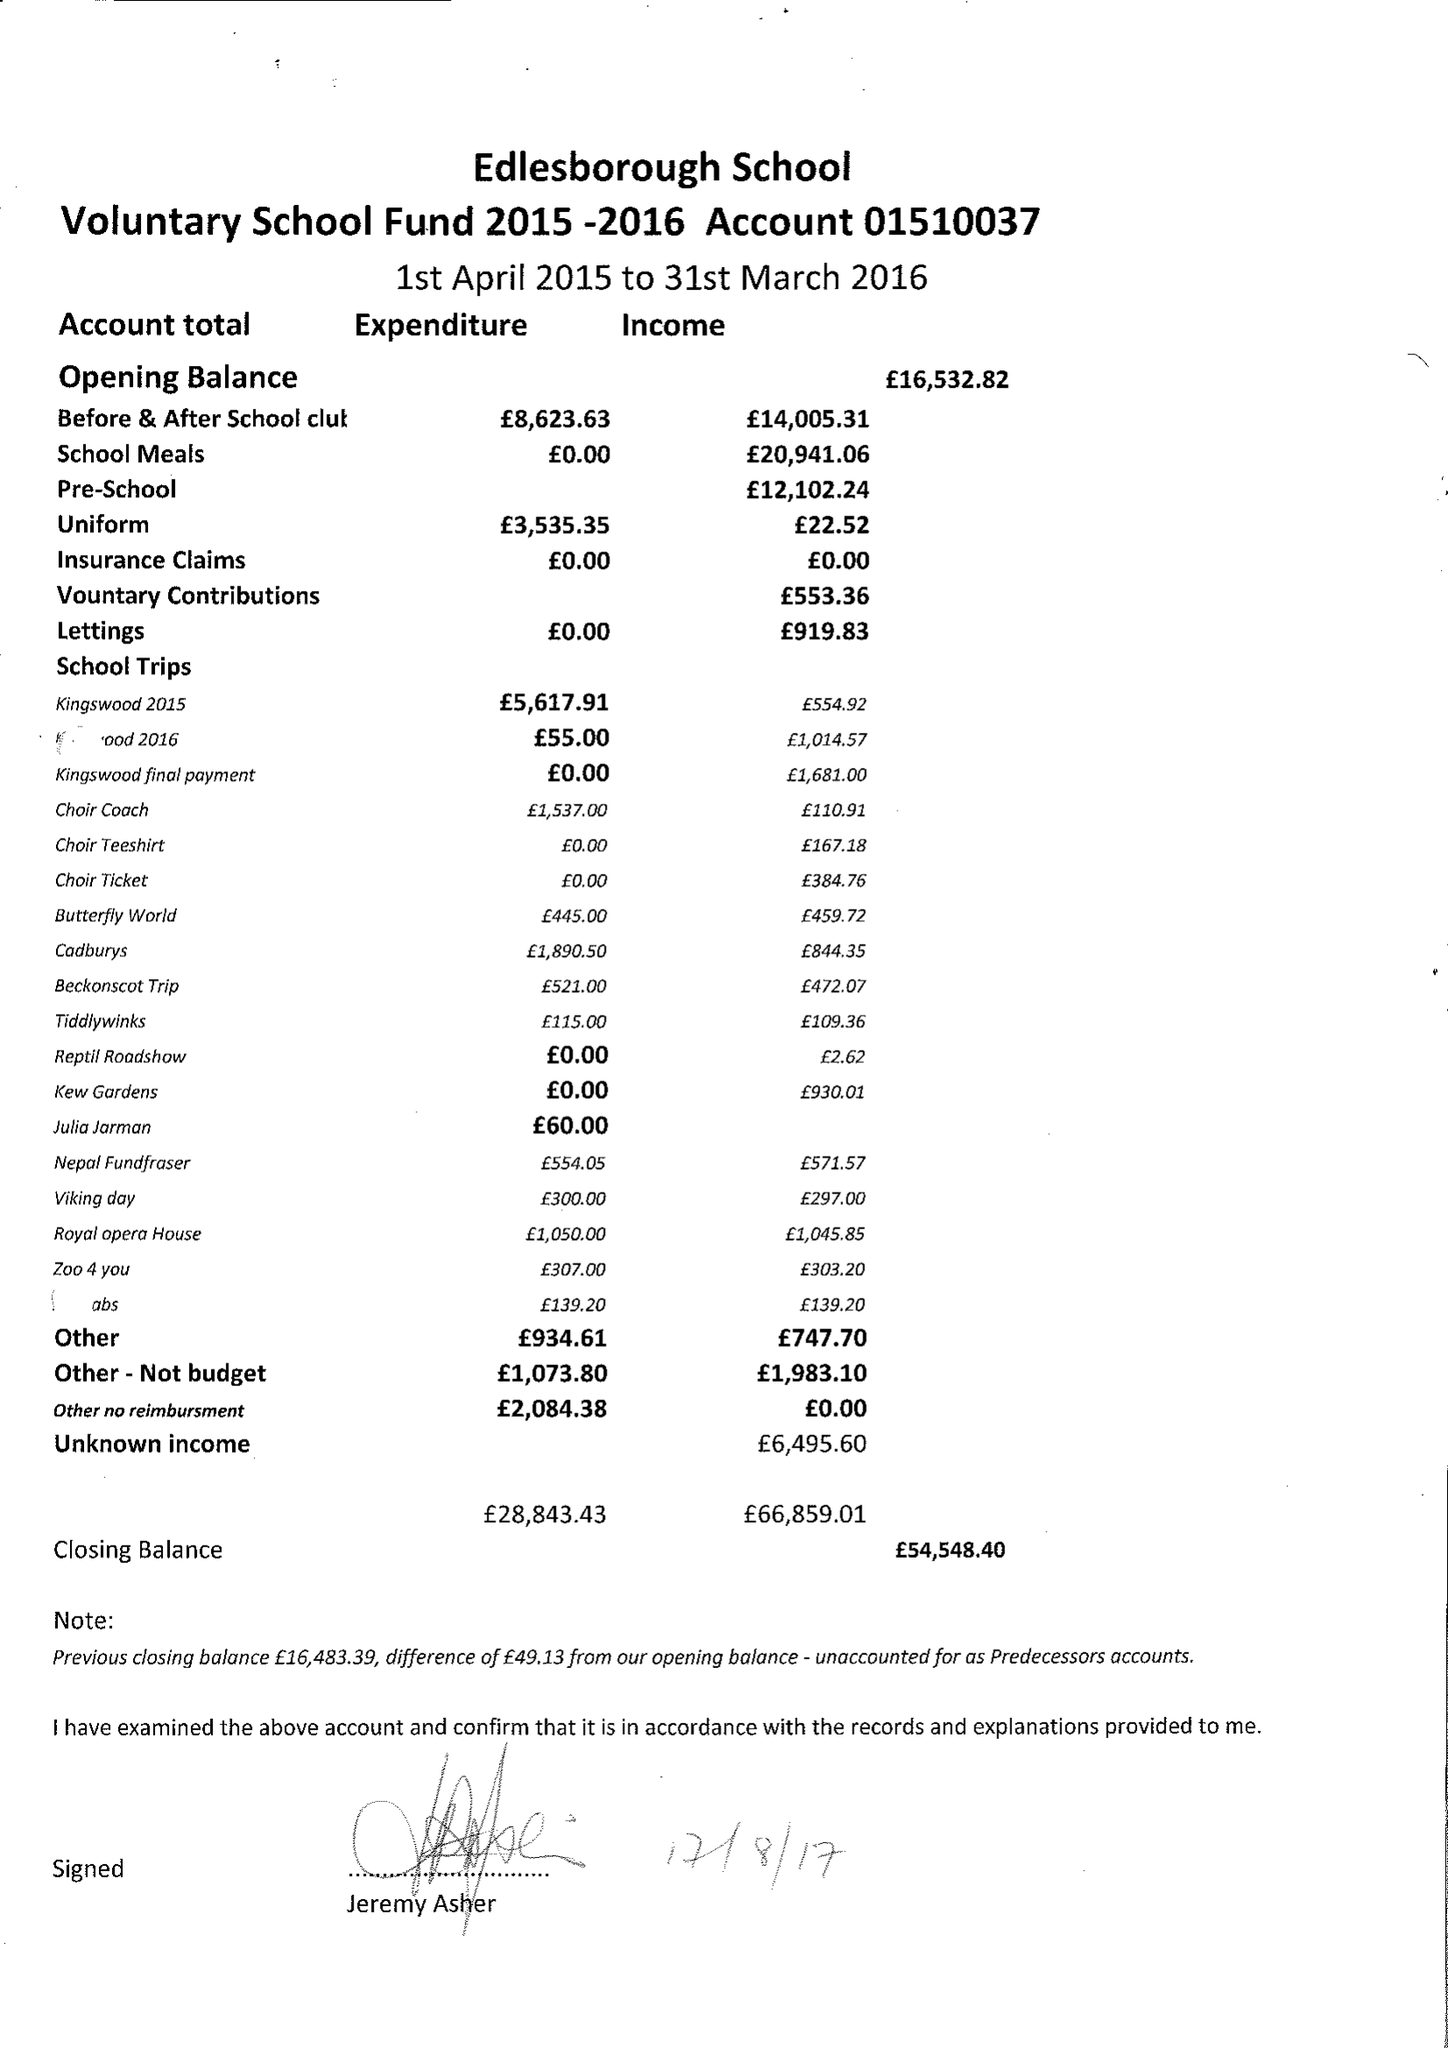What is the value for the charity_name?
Answer the question using a single word or phrase. Edlesborough School Fund 